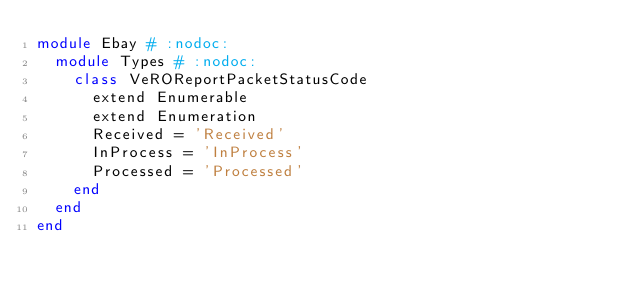<code> <loc_0><loc_0><loc_500><loc_500><_Ruby_>module Ebay # :nodoc:
  module Types # :nodoc:
    class VeROReportPacketStatusCode
      extend Enumerable
      extend Enumeration
      Received = 'Received'
      InProcess = 'InProcess'
      Processed = 'Processed'
    end
  end
end

</code> 